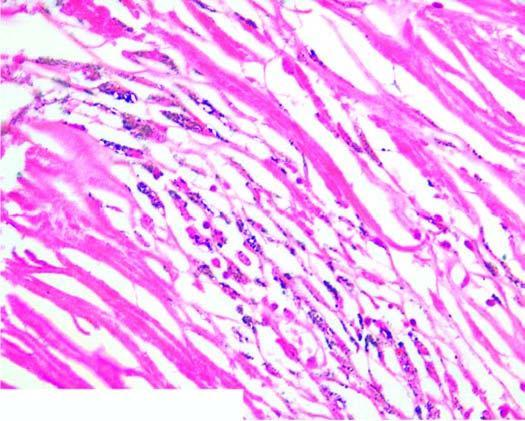what shows bright fibres of silica?
Answer the question using a single word or phrase. Polarising microscopy in photomicrograph on right 